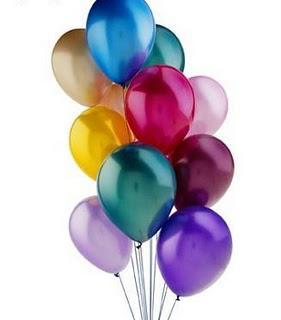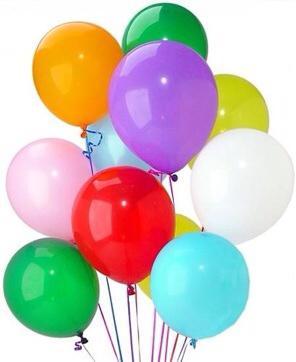The first image is the image on the left, the second image is the image on the right. Evaluate the accuracy of this statement regarding the images: "An image shows an upward view of at least one balloon on a string ascending into a cloud-studded blue sky.". Is it true? Answer yes or no. No. 